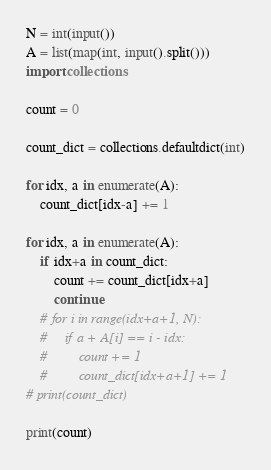Convert code to text. <code><loc_0><loc_0><loc_500><loc_500><_Python_>N = int(input())
A = list(map(int, input().split()))
import collections

count = 0

count_dict = collections.defaultdict(int)

for idx, a in enumerate(A):
    count_dict[idx-a] += 1

for idx, a in enumerate(A):
    if idx+a in count_dict:
        count += count_dict[idx+a]
        continue
    # for i in range(idx+a+1, N):
    #     if a + A[i] == i - idx:
    #         count += 1
    #         count_dict[idx+a+1] += 1
# print(count_dict)

print(count)</code> 